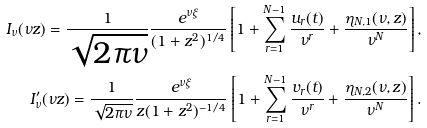Convert formula to latex. <formula><loc_0><loc_0><loc_500><loc_500>I _ { \nu } ( \nu z ) = \frac { 1 } { \sqrt { 2 \pi \nu } } \frac { e ^ { \nu \xi } } { ( 1 + z ^ { 2 } ) ^ { 1 / 4 } } \left [ 1 + \sum _ { r = 1 } ^ { N - 1 } \frac { u _ { r } ( t ) } { \nu ^ { r } } + \frac { \eta _ { N , 1 } ( \nu , z ) } { \nu ^ { N } } \right ] , & \\ I ^ { \prime } _ { \nu } ( \nu z ) = \frac { 1 } { \sqrt { 2 \pi \nu } } \frac { e ^ { \nu \xi } } { z ( 1 + z ^ { 2 } ) ^ { - 1 / 4 } } \left [ 1 + \sum _ { r = 1 } ^ { N - 1 } \frac { v _ { r } ( t ) } { \nu ^ { r } } + \frac { \eta _ { N , 2 } ( \nu , z ) } { \nu ^ { N } } \right ] . &</formula> 